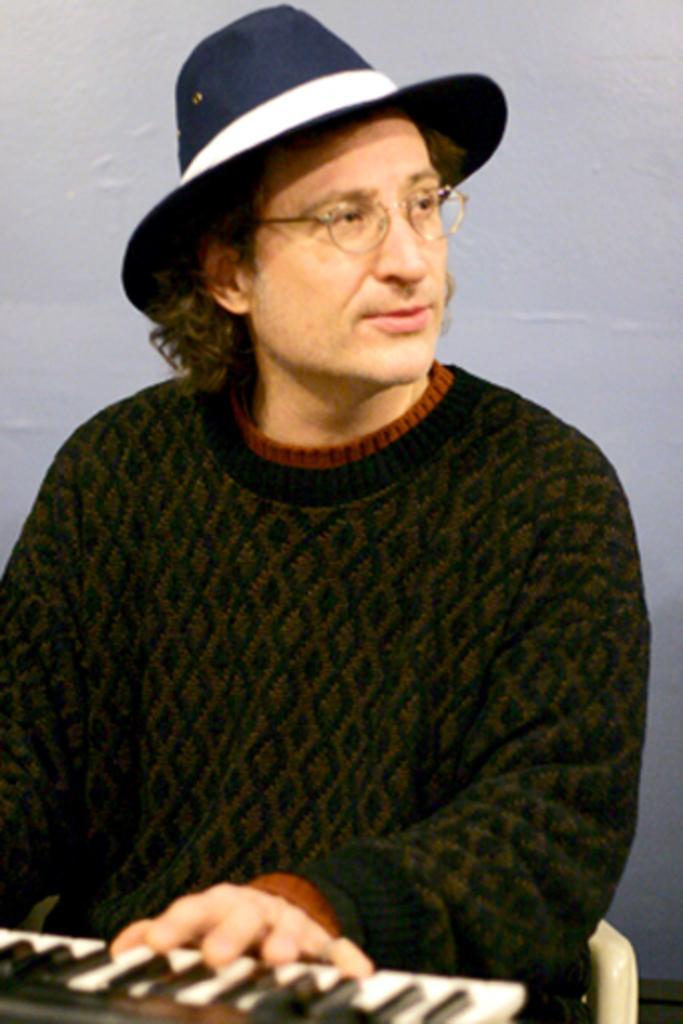In one or two sentences, can you explain what this image depicts? This picture consists of a man sitting on a chair in the center and is playing a musical instrument which is in front of him. He is wearing a blue colour hat. 